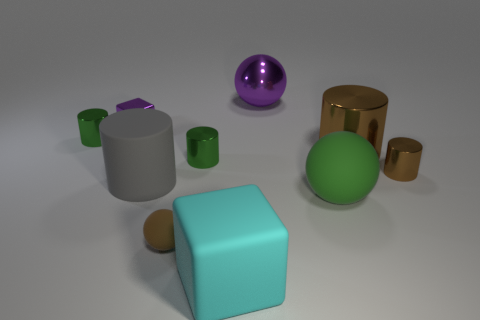Is there anything else that is the same shape as the green rubber object?
Provide a succinct answer. Yes. Is the big cyan thing made of the same material as the big cylinder on the right side of the cyan matte block?
Ensure brevity in your answer.  No. What number of yellow objects are either large metallic things or spheres?
Make the answer very short. 0. Is there a matte ball?
Offer a very short reply. Yes. There is a brown shiny cylinder to the left of the tiny cylinder that is to the right of the purple sphere; are there any big metallic objects that are behind it?
Offer a very short reply. Yes. Is there anything else that is the same size as the purple metal sphere?
Keep it short and to the point. Yes. There is a gray thing; is its shape the same as the green thing that is to the left of the small ball?
Keep it short and to the point. Yes. There is a large cylinder behind the rubber cylinder behind the green object to the right of the large purple metallic sphere; what is its color?
Ensure brevity in your answer.  Brown. What number of objects are either tiny green shiny cylinders on the left side of the gray matte cylinder or tiny green things that are behind the green rubber sphere?
Give a very brief answer. 2. What number of other objects are there of the same color as the big rubber cube?
Provide a short and direct response. 0. 